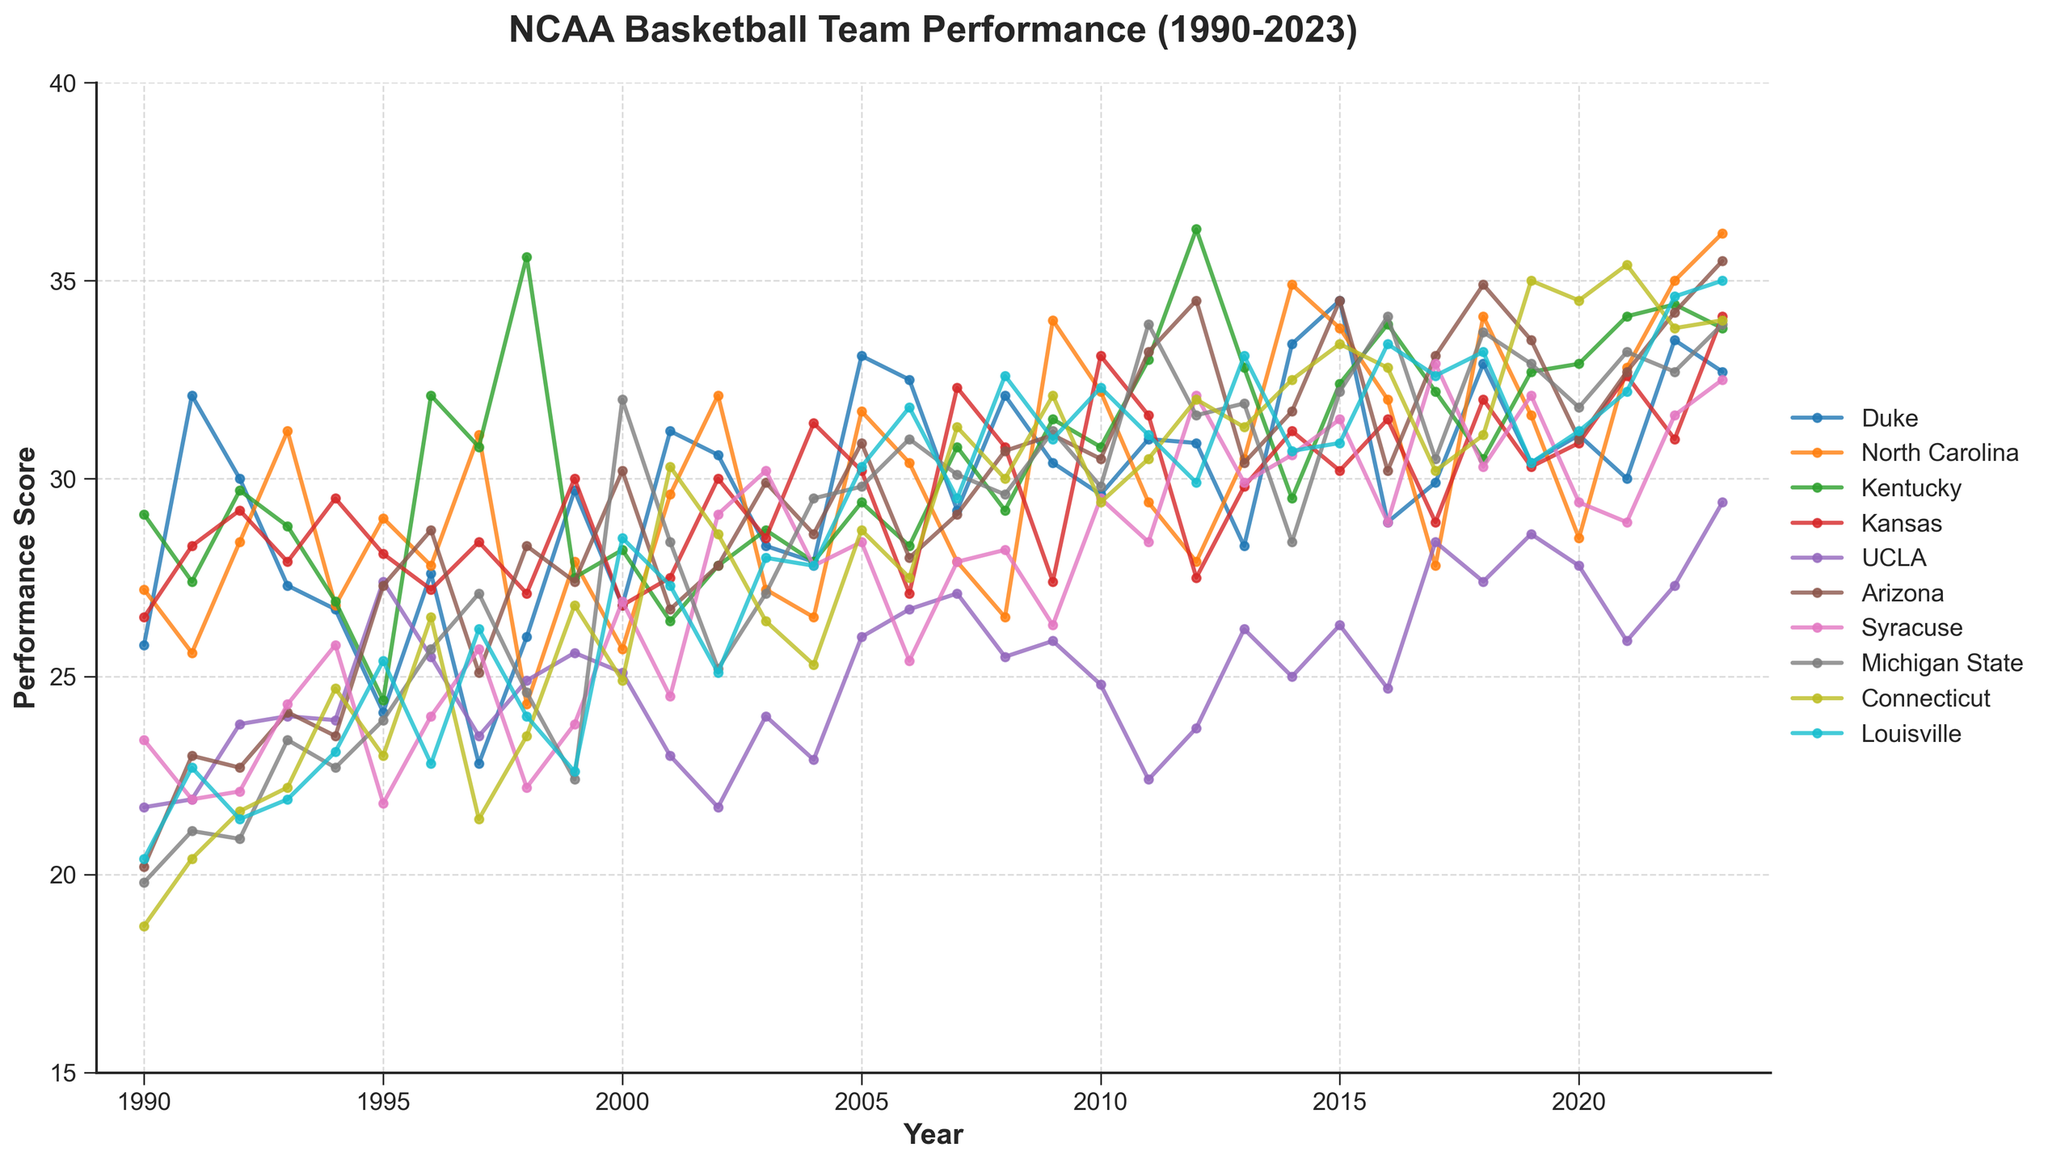What is the range of years shown in the plot? The x-axis of the plot ranges from 1990 to 2023. The title "NCAA Basketball Team Performance (1990-2023)" confirms this range.
Answer: 1990 to 2023 Which team had the highest performance score in 2023? By looking at the 2023 performance scores, North Carolina has the highest value at around 36.2.
Answer: North Carolina How many teams are represented in the plot? The legend lists the teams which are 10 in total: Duke, North Carolina, Kentucky, Kansas, UCLA, Arizona, Syracuse, Michigan State, Connecticut, and Louisville.
Answer: 10 What is the average performance score for Duke during the 1990s? The performance scores for Duke from 1990 to 1999 are 25.8, 32.1, 30.0, 27.3, 26.7, 24.1, 27.6, 22.8, 26.0, 29.7. Summing these values gives 272.1. Dividing by the number of years (10), we get an average of 27.21.
Answer: 27.21 Which team showed the greatest increase in performance score between 2018 and 2019? By examining the performance change from 2018 to 2019, Connecticut increased from 31.1 to 35.0, showing the greatest increase of 3.9.
Answer: Connecticut Compare the performance scores of UCLA and Arizona in 2010. Which team performed better? By checking the performance scores in 2010, Arizona has a score of 30.5, while UCLA has a score of 24.8.
Answer: Arizona Which year did Louisville have its highest performance score and what was that score? By looking through the plot, Louisville had its highest performance score in 2022 with a score of 35.0.
Answer: 2022 and 35.0 What is the trend of Michigan State's performance score from 1995 to 2000? From 1995 to 2000, Michigan State's performance scores were 23.9, 25.7, 27.1, 24.6, 22.4, and 32.0, respectively, indicating an overall increasing trend with a dip in the middle.
Answer: Increasing with a dip By how much did Kansas's performance score change from 2007 to 2008? Kansas's scores were 32.3 in 2007 and 30.8 in 2008, a decrease of 1.5 points.
Answer: Decreased by 1.5 points Which team had the most consistent performance score (smallest variation) throughout the data range? By visually inspecting the plot, Kansas has relatively small fluctuations compared to other teams.
Answer: Kansas 